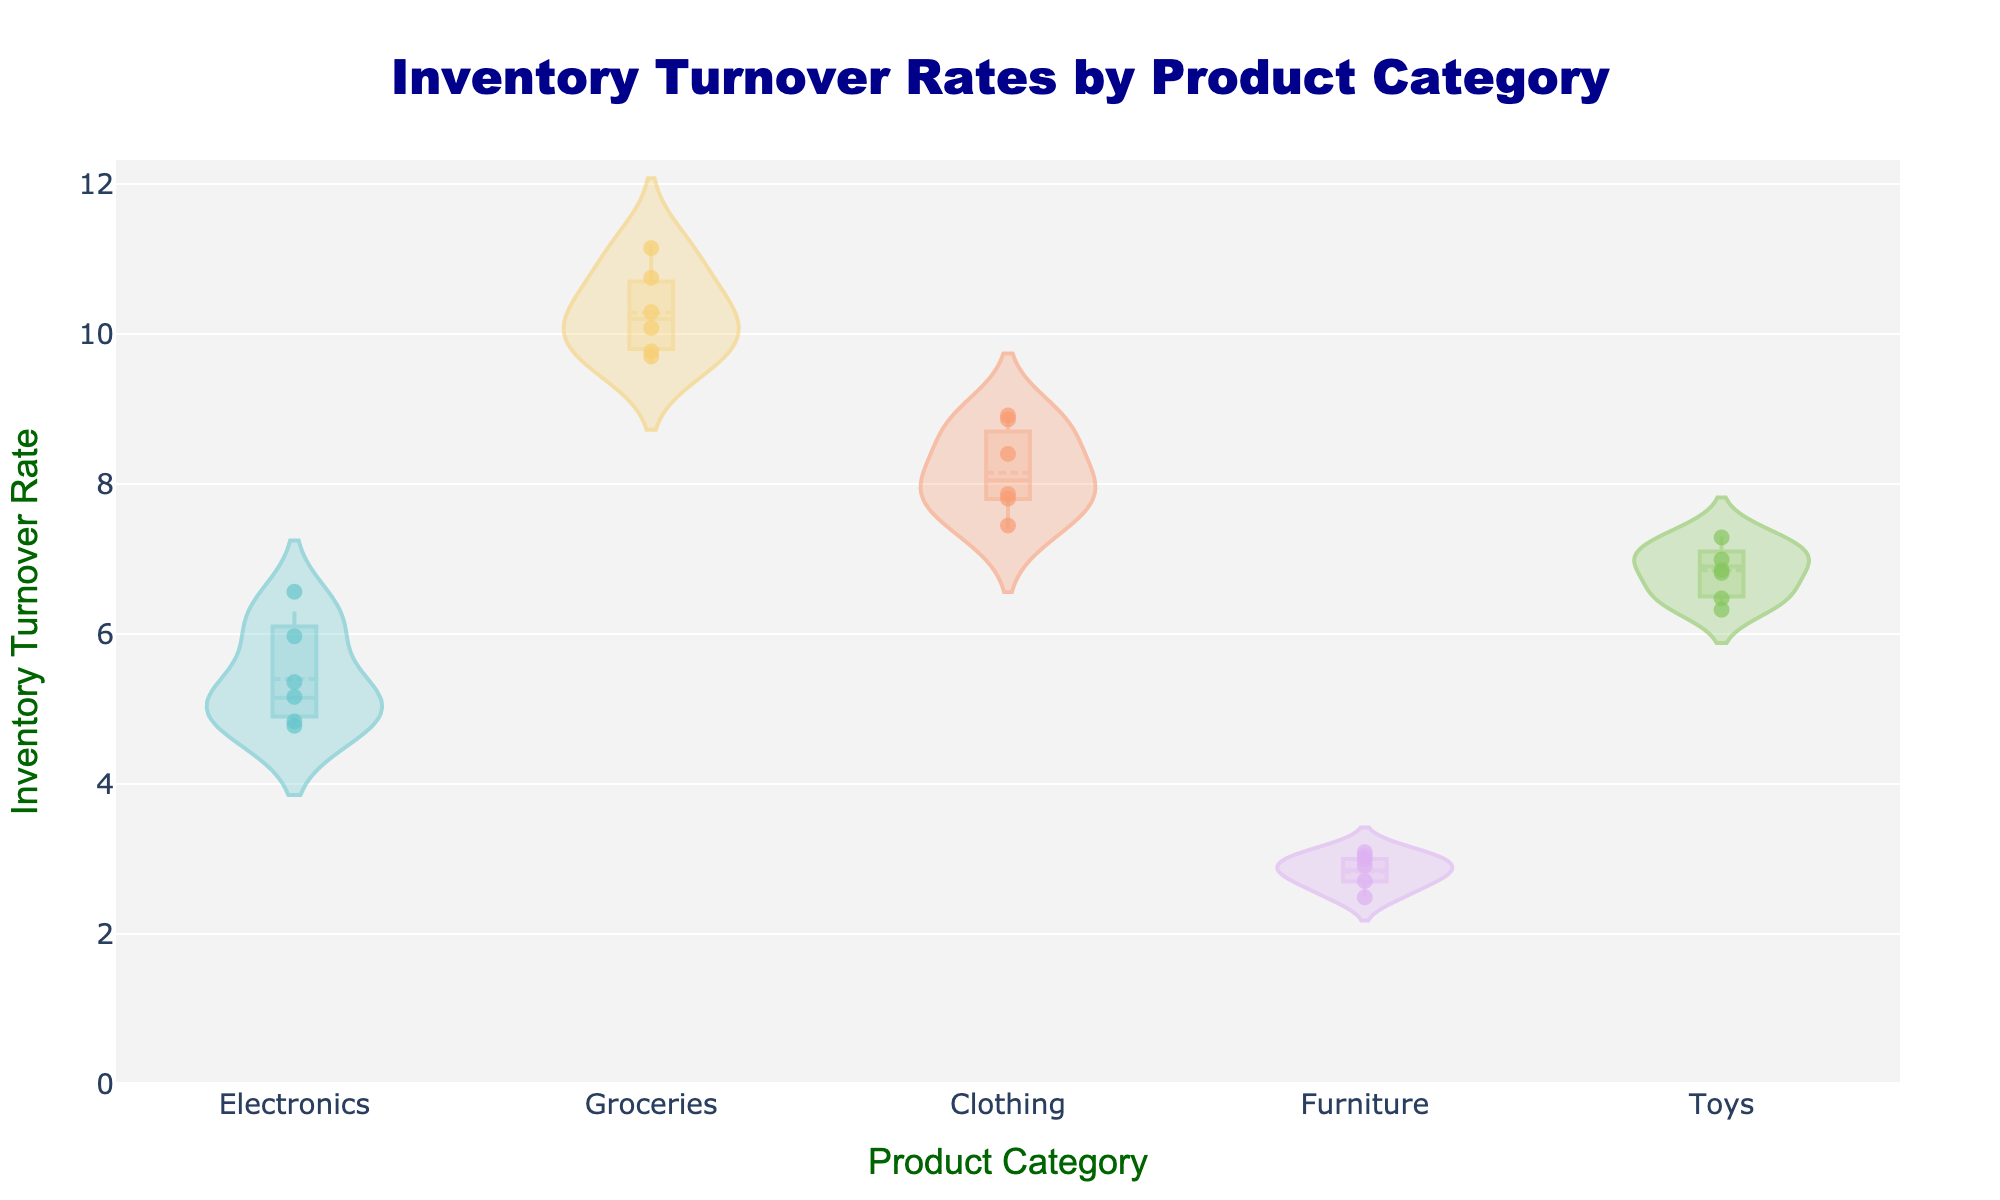What is the title of the figure? The title is displayed prominently at the top of the chart: "Inventory Turnover Rates by Product Category".
Answer: Inventory Turnover Rates by Product Category What product category has the highest mean inventory turnover rate? The mean inventory turnover rate is shown as a line within each violin plot. The Grocery category has the highest mean rate as depicted by its mean line.
Answer: Groceries How many categories are displayed in the figure? Each unique x-axis label represents a product category. There are labels for Electronics, Groceries, Clothing, Furniture, and Toys, making a total of five categories.
Answer: Five Which category has the lowest inventory turnover rate? The Furniture category shows the lowest range of values on the y-axis, indicating it has the lowest inventory turnover rate.
Answer: Furniture What's the approximate range of inventory turnover rates for the Clothing category? The range can be observed from the extent of the violin plot for Clothing; it extends from around 7.4 to 8.9.
Answer: About 7.4 to 8.9 Compare the spread of Inventory Turnover Rates between Electronics and Toys. Which category has a larger spread? The spread is observed by looking at the width of the violin plots horizontally. The Toys category shows a larger spread compared to Electronics, indicating more variability in its rates.
Answer: Toys What is the median inventory turnover rate for the Electronics category? The median is shown as an inner white dot in the violin plot. For Electronics, the median appears to be around 5.
Answer: Around 5 How do the jittered points contribute to interpreting the data? Jittered points help visualize the distribution of individual data points, giving a clearer picture of density and variability within each category.
Answer: They show individual data points Which category has its inventory turnover rates closest to each other? Based on the tightness and narrowness of the violin plot, the Furniture category shows the least dispersion, indicating the closest rates to each other.
Answer: Furniture Is there any overlap in the inventory turnover rates between the Groceries and Clothing categories? By comparing the vertical extents of both violin plots, there's a slight overlap where Clothing's max rate of 8.9 coincides partly with Groceries' lower rates around 9.
Answer: Yes 